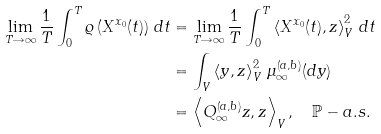Convert formula to latex. <formula><loc_0><loc_0><loc_500><loc_500>\lim _ { T \rightarrow \infty } \frac { 1 } { T } \int _ { 0 } ^ { T } \varrho \left ( X ^ { x _ { 0 } } ( t ) \right ) \, d t & = \lim _ { T \rightarrow \infty } \frac { 1 } { T } \int _ { 0 } ^ { T } \left \langle X ^ { x _ { 0 } } ( t ) , z \right \rangle _ { V } ^ { 2 } \, d t \\ & = \int _ { V } \left \langle y , z \right \rangle _ { V } ^ { 2 } \, \mu _ { \infty } ^ { ( a , b ) } ( d y ) \\ & = \left \langle Q _ { \infty } ^ { ( a , b ) } z , z \right \rangle _ { V } , \quad \mathbb { P } - a . s .</formula> 